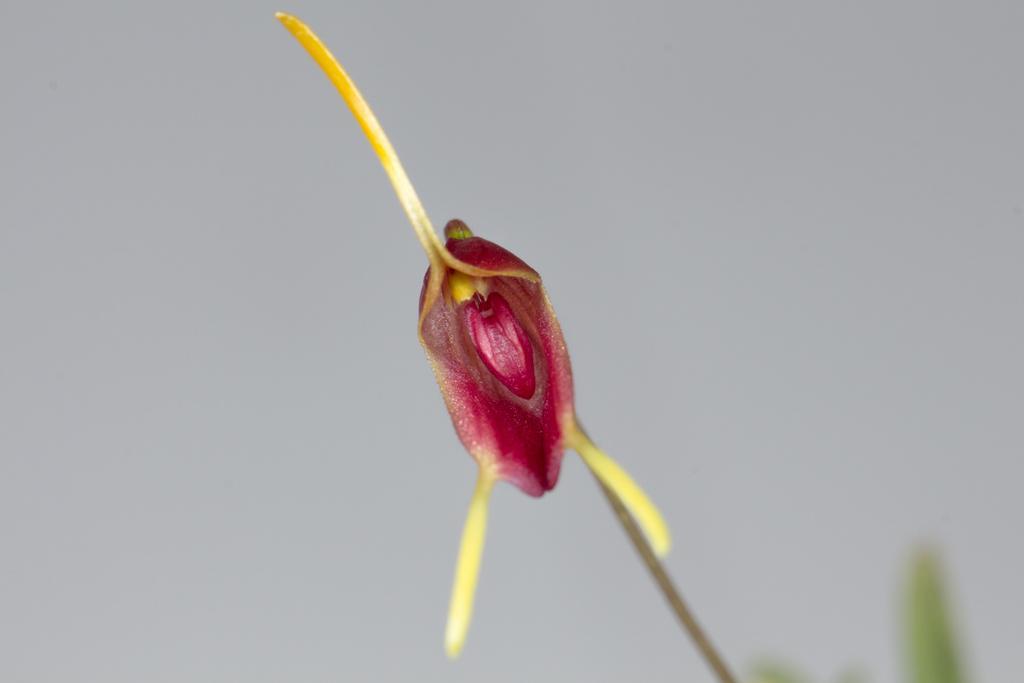How would you summarize this image in a sentence or two? In this image there is a flower to the plant having leaves. Background there is sky. 